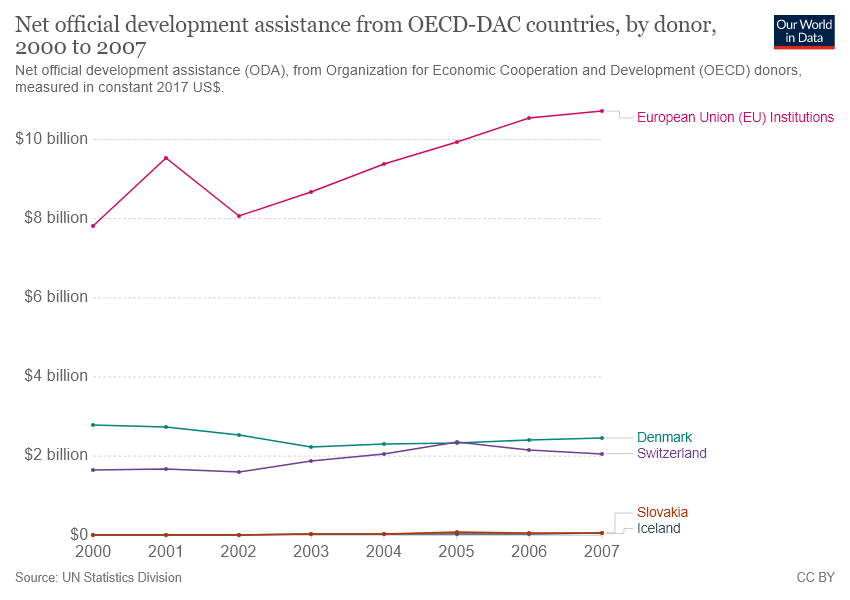How do the contributions of Slovakia and Iceland compare to those of Denmark and Switzerland? Slovakia and Iceland contributed much less in ODA as compared to Denmark and Switzerland throughout the 2000-2007 period. According to the graph, the contributions of Slovakia and Iceland are so minimal they nearly fall at the $0 line on the graph, indicating that their development assistance levels were significantly lower compared to the more sizable and stable contributions from Denmark and Switzerland. 